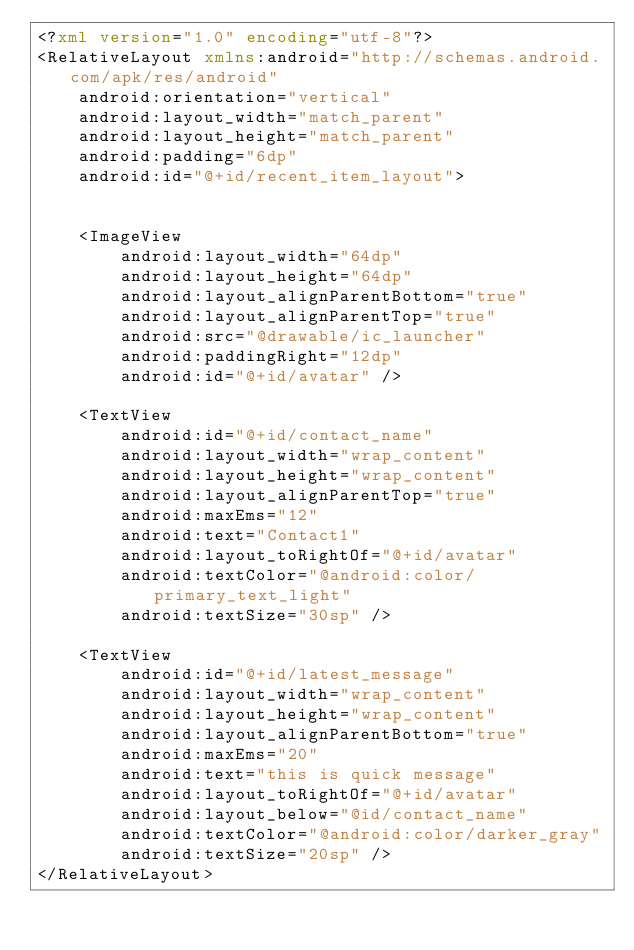<code> <loc_0><loc_0><loc_500><loc_500><_XML_><?xml version="1.0" encoding="utf-8"?>
<RelativeLayout xmlns:android="http://schemas.android.com/apk/res/android"
    android:orientation="vertical"
    android:layout_width="match_parent"
    android:layout_height="match_parent"
    android:padding="6dp"
    android:id="@+id/recent_item_layout">


    <ImageView
        android:layout_width="64dp"
        android:layout_height="64dp"
        android:layout_alignParentBottom="true"
        android:layout_alignParentTop="true"
        android:src="@drawable/ic_launcher"
        android:paddingRight="12dp"
        android:id="@+id/avatar" />

    <TextView
        android:id="@+id/contact_name"
        android:layout_width="wrap_content"
        android:layout_height="wrap_content"
        android:layout_alignParentTop="true"
        android:maxEms="12"
        android:text="Contact1"
        android:layout_toRightOf="@+id/avatar"
        android:textColor="@android:color/primary_text_light"
        android:textSize="30sp" />

    <TextView
        android:id="@+id/latest_message"
        android:layout_width="wrap_content"
        android:layout_height="wrap_content"
        android:layout_alignParentBottom="true"
        android:maxEms="20"
        android:text="this is quick message"
        android:layout_toRightOf="@+id/avatar"
        android:layout_below="@id/contact_name"
        android:textColor="@android:color/darker_gray"
        android:textSize="20sp" />
</RelativeLayout></code> 